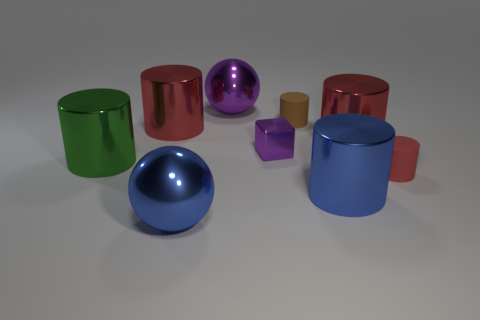Are there any patterns or symmetry in the arrangement of the objects? There isn't a clear pattern or symmetry in the arrangement; the objects seem randomly placed with no discernible order. Could you infer the size relation between these objects? While we can't measure the objects precisely, their relative sizes suggest a variety of scales, with some objects being small enough to hold in one hand and others that might require both hands. 